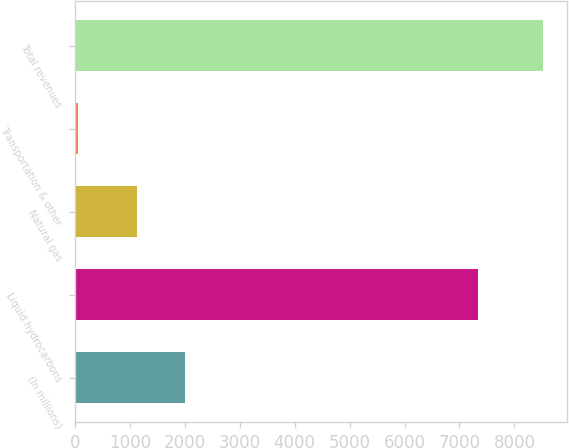Convert chart to OTSL. <chart><loc_0><loc_0><loc_500><loc_500><bar_chart><fcel>(In millions)<fcel>Liquid hydrocarbons<fcel>Natural gas<fcel>Transportation & other<fcel>Total revenues<nl><fcel>2009<fcel>7343<fcel>1126<fcel>55<fcel>8524<nl></chart> 